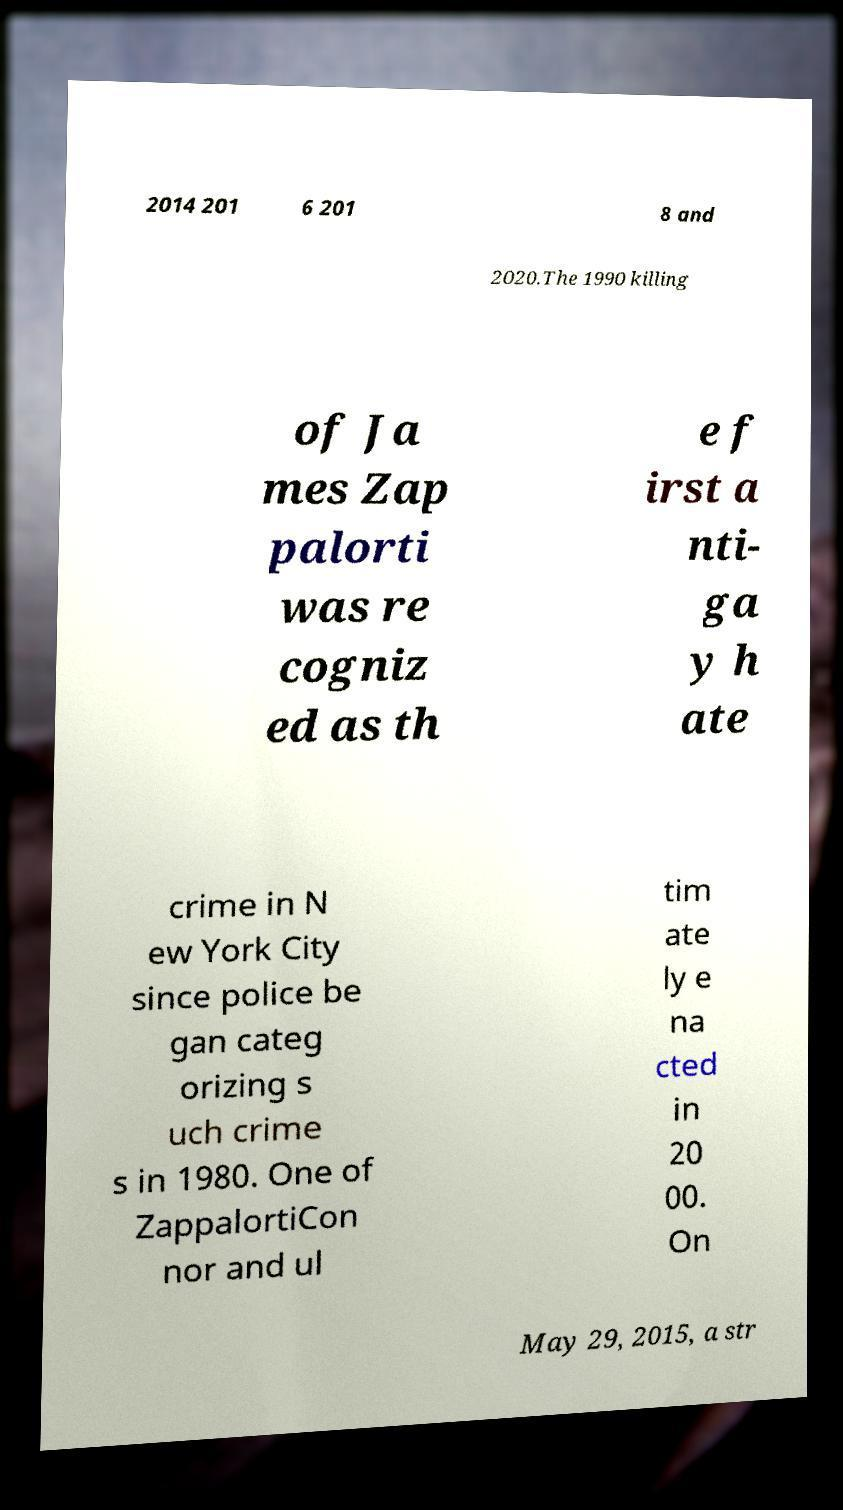Could you assist in decoding the text presented in this image and type it out clearly? 2014 201 6 201 8 and 2020.The 1990 killing of Ja mes Zap palorti was re cogniz ed as th e f irst a nti- ga y h ate crime in N ew York City since police be gan categ orizing s uch crime s in 1980. One of ZappalortiCon nor and ul tim ate ly e na cted in 20 00. On May 29, 2015, a str 